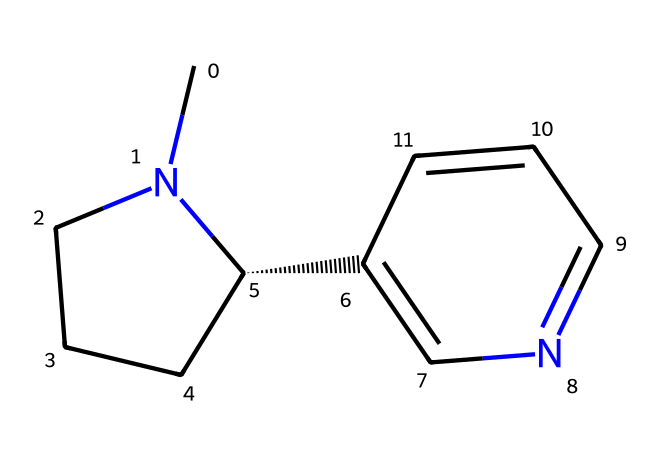What is the IUPAC name of this chemical? The SMILES representation corresponds to a specific structure known as nicotine. The IUPAC name for nicotine is 3-(1-methylpyrrolidin-2-yl)pyridine.
Answer: nicotine How many nitrogen atoms are present in the structure? Analyzing the SMILES, we identify two nitrogen atoms in the structure, which are essential for its classification as an alkaloid.
Answer: 2 What is the total number of carbon atoms in this chemical? The SMILES representation indicates the presence of ten carbon atoms, which can be counted from the chemical structure itself.
Answer: 10 Which part of this chemical contributes to its addictive nature? The nitrogen-containing pyridine and pyrrolidine rings in the structure participate in interactions with nicotinic acetylcholine receptors in the brain, contributing to its addictive properties.
Answer: nitrogen rings How would you categorize this compound in terms of its effects on the central nervous system? Nicotine stimulates the central nervous system by acting as a stimulant, leading to increased alertness and dopamine release, which is linked to its addictive nature.
Answer: stimulant What role does the methyl group play in this structure? The methyl group attached to the nitrogen enhances the lipophilicity of the molecule, aiding its absorption and penetration through biological membranes, which is critical for its effects.
Answer: enhances absorption 